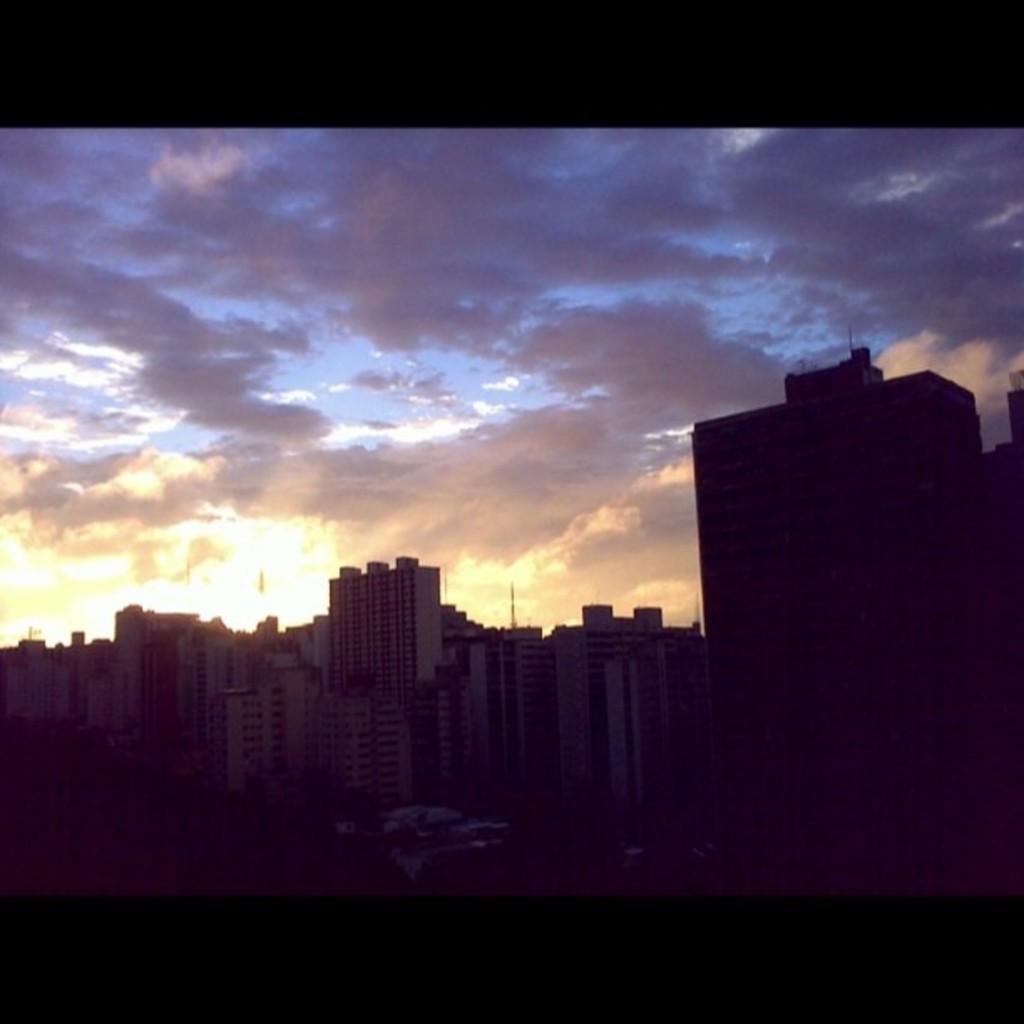Please provide a concise description of this image. In this picture we can see buildings and in the background we can see the sky with clouds. 